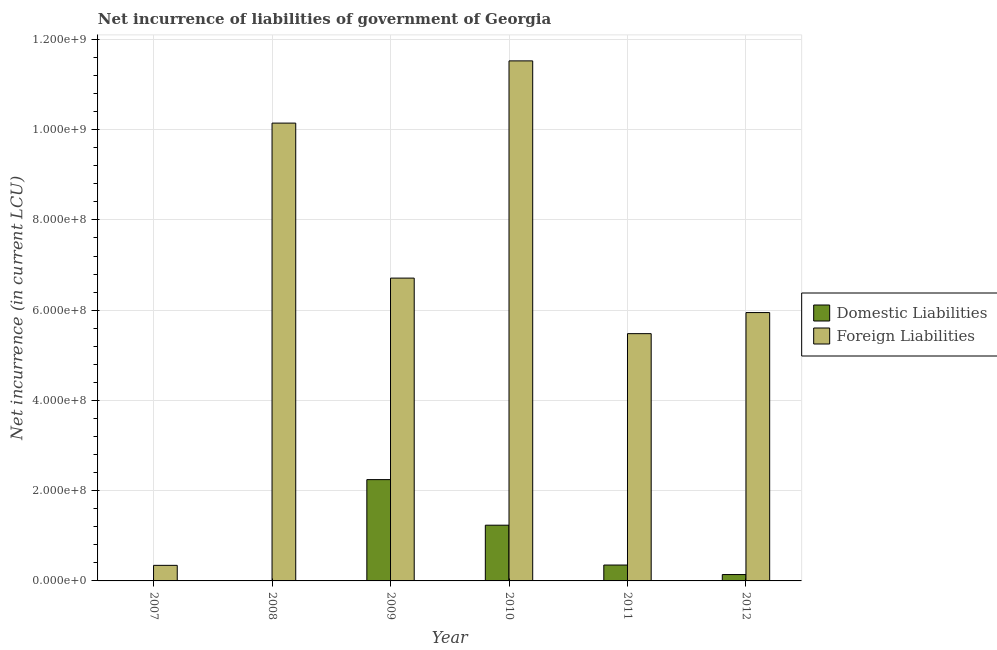How many bars are there on the 1st tick from the left?
Provide a short and direct response. 1. How many bars are there on the 3rd tick from the right?
Keep it short and to the point. 2. In how many cases, is the number of bars for a given year not equal to the number of legend labels?
Your answer should be very brief. 2. What is the net incurrence of foreign liabilities in 2008?
Keep it short and to the point. 1.01e+09. Across all years, what is the maximum net incurrence of domestic liabilities?
Offer a terse response. 2.24e+08. Across all years, what is the minimum net incurrence of foreign liabilities?
Your response must be concise. 3.45e+07. In which year was the net incurrence of foreign liabilities maximum?
Ensure brevity in your answer.  2010. What is the total net incurrence of domestic liabilities in the graph?
Make the answer very short. 3.97e+08. What is the difference between the net incurrence of domestic liabilities in 2009 and that in 2010?
Ensure brevity in your answer.  1.01e+08. What is the difference between the net incurrence of foreign liabilities in 2012 and the net incurrence of domestic liabilities in 2009?
Provide a succinct answer. -7.64e+07. What is the average net incurrence of foreign liabilities per year?
Give a very brief answer. 6.69e+08. In how many years, is the net incurrence of foreign liabilities greater than 800000000 LCU?
Offer a very short reply. 2. What is the ratio of the net incurrence of foreign liabilities in 2008 to that in 2012?
Your response must be concise. 1.71. Is the difference between the net incurrence of domestic liabilities in 2010 and 2011 greater than the difference between the net incurrence of foreign liabilities in 2010 and 2011?
Keep it short and to the point. No. What is the difference between the highest and the second highest net incurrence of foreign liabilities?
Keep it short and to the point. 1.38e+08. What is the difference between the highest and the lowest net incurrence of domestic liabilities?
Give a very brief answer. 2.24e+08. In how many years, is the net incurrence of domestic liabilities greater than the average net incurrence of domestic liabilities taken over all years?
Give a very brief answer. 2. Is the sum of the net incurrence of foreign liabilities in 2009 and 2011 greater than the maximum net incurrence of domestic liabilities across all years?
Your answer should be compact. Yes. How many bars are there?
Provide a succinct answer. 10. How many years are there in the graph?
Your answer should be very brief. 6. Are the values on the major ticks of Y-axis written in scientific E-notation?
Provide a short and direct response. Yes. Does the graph contain grids?
Your response must be concise. Yes. How many legend labels are there?
Ensure brevity in your answer.  2. What is the title of the graph?
Provide a short and direct response. Net incurrence of liabilities of government of Georgia. What is the label or title of the Y-axis?
Provide a short and direct response. Net incurrence (in current LCU). What is the Net incurrence (in current LCU) of Foreign Liabilities in 2007?
Keep it short and to the point. 3.45e+07. What is the Net incurrence (in current LCU) in Foreign Liabilities in 2008?
Provide a succinct answer. 1.01e+09. What is the Net incurrence (in current LCU) in Domestic Liabilities in 2009?
Offer a terse response. 2.24e+08. What is the Net incurrence (in current LCU) of Foreign Liabilities in 2009?
Make the answer very short. 6.71e+08. What is the Net incurrence (in current LCU) of Domestic Liabilities in 2010?
Offer a very short reply. 1.24e+08. What is the Net incurrence (in current LCU) of Foreign Liabilities in 2010?
Your answer should be compact. 1.15e+09. What is the Net incurrence (in current LCU) of Domestic Liabilities in 2011?
Make the answer very short. 3.52e+07. What is the Net incurrence (in current LCU) in Foreign Liabilities in 2011?
Give a very brief answer. 5.48e+08. What is the Net incurrence (in current LCU) of Domestic Liabilities in 2012?
Provide a short and direct response. 1.41e+07. What is the Net incurrence (in current LCU) of Foreign Liabilities in 2012?
Give a very brief answer. 5.95e+08. Across all years, what is the maximum Net incurrence (in current LCU) of Domestic Liabilities?
Give a very brief answer. 2.24e+08. Across all years, what is the maximum Net incurrence (in current LCU) in Foreign Liabilities?
Provide a short and direct response. 1.15e+09. Across all years, what is the minimum Net incurrence (in current LCU) in Domestic Liabilities?
Ensure brevity in your answer.  0. Across all years, what is the minimum Net incurrence (in current LCU) in Foreign Liabilities?
Your answer should be very brief. 3.45e+07. What is the total Net incurrence (in current LCU) in Domestic Liabilities in the graph?
Provide a short and direct response. 3.97e+08. What is the total Net incurrence (in current LCU) in Foreign Liabilities in the graph?
Give a very brief answer. 4.02e+09. What is the difference between the Net incurrence (in current LCU) in Foreign Liabilities in 2007 and that in 2008?
Make the answer very short. -9.80e+08. What is the difference between the Net incurrence (in current LCU) in Foreign Liabilities in 2007 and that in 2009?
Offer a very short reply. -6.37e+08. What is the difference between the Net incurrence (in current LCU) of Foreign Liabilities in 2007 and that in 2010?
Your answer should be very brief. -1.12e+09. What is the difference between the Net incurrence (in current LCU) in Foreign Liabilities in 2007 and that in 2011?
Your answer should be compact. -5.14e+08. What is the difference between the Net incurrence (in current LCU) in Foreign Liabilities in 2007 and that in 2012?
Provide a short and direct response. -5.60e+08. What is the difference between the Net incurrence (in current LCU) in Foreign Liabilities in 2008 and that in 2009?
Give a very brief answer. 3.44e+08. What is the difference between the Net incurrence (in current LCU) of Foreign Liabilities in 2008 and that in 2010?
Make the answer very short. -1.38e+08. What is the difference between the Net incurrence (in current LCU) in Foreign Liabilities in 2008 and that in 2011?
Keep it short and to the point. 4.67e+08. What is the difference between the Net incurrence (in current LCU) of Foreign Liabilities in 2008 and that in 2012?
Give a very brief answer. 4.20e+08. What is the difference between the Net incurrence (in current LCU) in Domestic Liabilities in 2009 and that in 2010?
Ensure brevity in your answer.  1.01e+08. What is the difference between the Net incurrence (in current LCU) of Foreign Liabilities in 2009 and that in 2010?
Your response must be concise. -4.81e+08. What is the difference between the Net incurrence (in current LCU) in Domestic Liabilities in 2009 and that in 2011?
Your answer should be compact. 1.89e+08. What is the difference between the Net incurrence (in current LCU) of Foreign Liabilities in 2009 and that in 2011?
Keep it short and to the point. 1.23e+08. What is the difference between the Net incurrence (in current LCU) in Domestic Liabilities in 2009 and that in 2012?
Give a very brief answer. 2.10e+08. What is the difference between the Net incurrence (in current LCU) of Foreign Liabilities in 2009 and that in 2012?
Ensure brevity in your answer.  7.64e+07. What is the difference between the Net incurrence (in current LCU) of Domestic Liabilities in 2010 and that in 2011?
Your answer should be compact. 8.83e+07. What is the difference between the Net incurrence (in current LCU) in Foreign Liabilities in 2010 and that in 2011?
Provide a short and direct response. 6.04e+08. What is the difference between the Net incurrence (in current LCU) in Domestic Liabilities in 2010 and that in 2012?
Offer a terse response. 1.09e+08. What is the difference between the Net incurrence (in current LCU) in Foreign Liabilities in 2010 and that in 2012?
Your answer should be compact. 5.58e+08. What is the difference between the Net incurrence (in current LCU) in Domestic Liabilities in 2011 and that in 2012?
Provide a succinct answer. 2.11e+07. What is the difference between the Net incurrence (in current LCU) in Foreign Liabilities in 2011 and that in 2012?
Your answer should be compact. -4.67e+07. What is the difference between the Net incurrence (in current LCU) of Domestic Liabilities in 2009 and the Net incurrence (in current LCU) of Foreign Liabilities in 2010?
Your answer should be very brief. -9.28e+08. What is the difference between the Net incurrence (in current LCU) of Domestic Liabilities in 2009 and the Net incurrence (in current LCU) of Foreign Liabilities in 2011?
Offer a terse response. -3.24e+08. What is the difference between the Net incurrence (in current LCU) in Domestic Liabilities in 2009 and the Net incurrence (in current LCU) in Foreign Liabilities in 2012?
Keep it short and to the point. -3.70e+08. What is the difference between the Net incurrence (in current LCU) in Domestic Liabilities in 2010 and the Net incurrence (in current LCU) in Foreign Liabilities in 2011?
Your answer should be compact. -4.24e+08. What is the difference between the Net incurrence (in current LCU) of Domestic Liabilities in 2010 and the Net incurrence (in current LCU) of Foreign Liabilities in 2012?
Provide a succinct answer. -4.71e+08. What is the difference between the Net incurrence (in current LCU) in Domestic Liabilities in 2011 and the Net incurrence (in current LCU) in Foreign Liabilities in 2012?
Provide a short and direct response. -5.60e+08. What is the average Net incurrence (in current LCU) in Domestic Liabilities per year?
Provide a succinct answer. 6.62e+07. What is the average Net incurrence (in current LCU) in Foreign Liabilities per year?
Keep it short and to the point. 6.69e+08. In the year 2009, what is the difference between the Net incurrence (in current LCU) in Domestic Liabilities and Net incurrence (in current LCU) in Foreign Liabilities?
Your response must be concise. -4.47e+08. In the year 2010, what is the difference between the Net incurrence (in current LCU) in Domestic Liabilities and Net incurrence (in current LCU) in Foreign Liabilities?
Offer a very short reply. -1.03e+09. In the year 2011, what is the difference between the Net incurrence (in current LCU) in Domestic Liabilities and Net incurrence (in current LCU) in Foreign Liabilities?
Provide a short and direct response. -5.13e+08. In the year 2012, what is the difference between the Net incurrence (in current LCU) in Domestic Liabilities and Net incurrence (in current LCU) in Foreign Liabilities?
Provide a short and direct response. -5.81e+08. What is the ratio of the Net incurrence (in current LCU) of Foreign Liabilities in 2007 to that in 2008?
Ensure brevity in your answer.  0.03. What is the ratio of the Net incurrence (in current LCU) of Foreign Liabilities in 2007 to that in 2009?
Your response must be concise. 0.05. What is the ratio of the Net incurrence (in current LCU) in Foreign Liabilities in 2007 to that in 2010?
Your answer should be compact. 0.03. What is the ratio of the Net incurrence (in current LCU) of Foreign Liabilities in 2007 to that in 2011?
Your answer should be very brief. 0.06. What is the ratio of the Net incurrence (in current LCU) in Foreign Liabilities in 2007 to that in 2012?
Provide a short and direct response. 0.06. What is the ratio of the Net incurrence (in current LCU) of Foreign Liabilities in 2008 to that in 2009?
Offer a terse response. 1.51. What is the ratio of the Net incurrence (in current LCU) in Foreign Liabilities in 2008 to that in 2010?
Your response must be concise. 0.88. What is the ratio of the Net incurrence (in current LCU) in Foreign Liabilities in 2008 to that in 2011?
Your response must be concise. 1.85. What is the ratio of the Net incurrence (in current LCU) of Foreign Liabilities in 2008 to that in 2012?
Your answer should be compact. 1.71. What is the ratio of the Net incurrence (in current LCU) of Domestic Liabilities in 2009 to that in 2010?
Provide a succinct answer. 1.82. What is the ratio of the Net incurrence (in current LCU) of Foreign Liabilities in 2009 to that in 2010?
Keep it short and to the point. 0.58. What is the ratio of the Net incurrence (in current LCU) of Domestic Liabilities in 2009 to that in 2011?
Offer a very short reply. 6.38. What is the ratio of the Net incurrence (in current LCU) in Foreign Liabilities in 2009 to that in 2011?
Provide a succinct answer. 1.22. What is the ratio of the Net incurrence (in current LCU) in Domestic Liabilities in 2009 to that in 2012?
Your answer should be compact. 15.92. What is the ratio of the Net incurrence (in current LCU) in Foreign Liabilities in 2009 to that in 2012?
Your answer should be compact. 1.13. What is the ratio of the Net incurrence (in current LCU) in Domestic Liabilities in 2010 to that in 2011?
Keep it short and to the point. 3.51. What is the ratio of the Net incurrence (in current LCU) of Foreign Liabilities in 2010 to that in 2011?
Your answer should be very brief. 2.1. What is the ratio of the Net incurrence (in current LCU) of Domestic Liabilities in 2010 to that in 2012?
Keep it short and to the point. 8.76. What is the ratio of the Net incurrence (in current LCU) of Foreign Liabilities in 2010 to that in 2012?
Offer a terse response. 1.94. What is the ratio of the Net incurrence (in current LCU) in Domestic Liabilities in 2011 to that in 2012?
Give a very brief answer. 2.5. What is the ratio of the Net incurrence (in current LCU) of Foreign Liabilities in 2011 to that in 2012?
Your response must be concise. 0.92. What is the difference between the highest and the second highest Net incurrence (in current LCU) in Domestic Liabilities?
Ensure brevity in your answer.  1.01e+08. What is the difference between the highest and the second highest Net incurrence (in current LCU) of Foreign Liabilities?
Provide a short and direct response. 1.38e+08. What is the difference between the highest and the lowest Net incurrence (in current LCU) of Domestic Liabilities?
Keep it short and to the point. 2.24e+08. What is the difference between the highest and the lowest Net incurrence (in current LCU) of Foreign Liabilities?
Ensure brevity in your answer.  1.12e+09. 